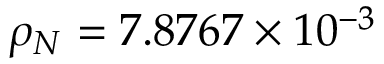<formula> <loc_0><loc_0><loc_500><loc_500>\rho _ { N } = 7 . 8 7 6 7 \times 1 0 ^ { - 3 }</formula> 